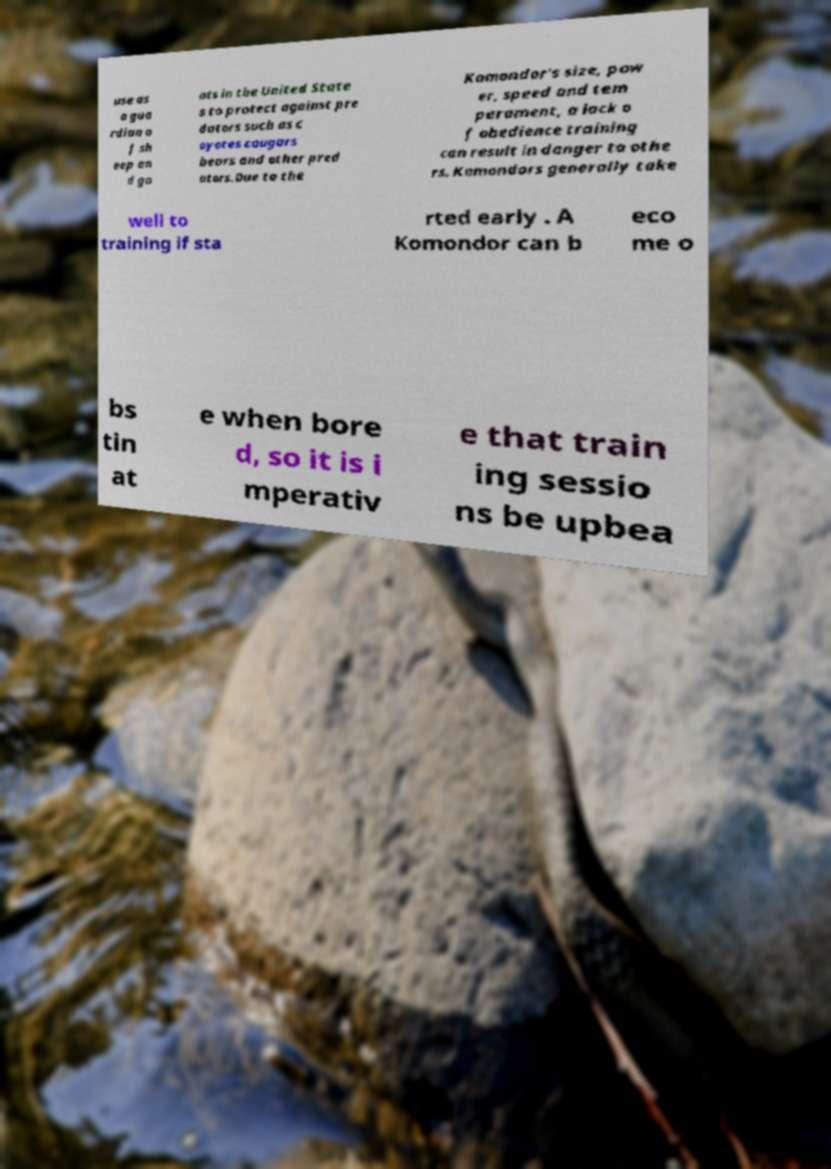For documentation purposes, I need the text within this image transcribed. Could you provide that? use as a gua rdian o f sh eep an d go ats in the United State s to protect against pre dators such as c oyotes cougars bears and other pred ators.Due to the Komondor's size, pow er, speed and tem perament, a lack o f obedience training can result in danger to othe rs. Komondors generally take well to training if sta rted early . A Komondor can b eco me o bs tin at e when bore d, so it is i mperativ e that train ing sessio ns be upbea 